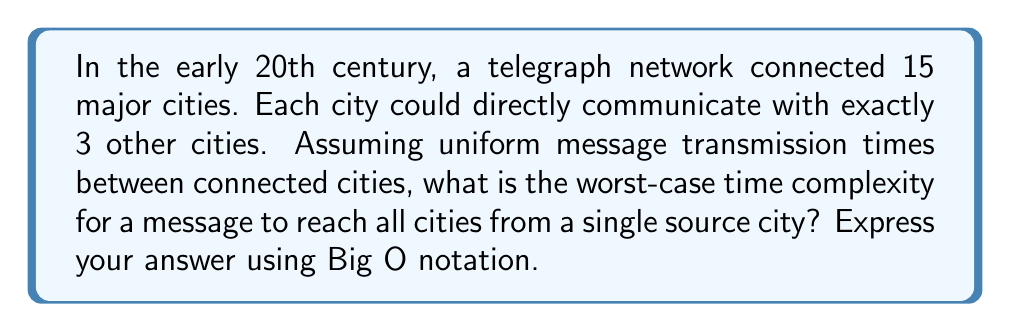Can you answer this question? To analyze this problem, we need to consider the structure of the network and how messages propagate through it:

1. Network structure:
   - 15 cities total
   - Each city connected to exactly 3 other cities
   - This forms a 3-regular graph

2. Message propagation:
   - Starting from a single source city
   - Each time step, the message can reach new cities connected to those that already have the message

3. Worst-case scenario:
   - The worst case occurs when the network has the maximum possible diameter
   - For a 3-regular graph with 15 vertices, the maximum diameter is approximately $\log_2(15)$ rounded up

4. Time complexity analysis:
   - In the first time step, the message reaches the source city and its 3 neighbors (4 cities total)
   - In each subsequent step, the message can reach at most twice as many new cities as the previous step
   - This forms a geometric progression: 1, 3, 6, 12, ...
   - The number of steps needed is $\log_2(15) \approx 3.91$, which rounds up to 4

5. Big O notation:
   - The time complexity is proportional to the number of steps
   - In Big O notation, we express this as $O(\log n)$, where $n$ is the number of cities

Therefore, the worst-case time complexity for the message to reach all cities is $O(\log n)$.
Answer: $O(\log n)$, where $n$ is the number of cities in the network. 